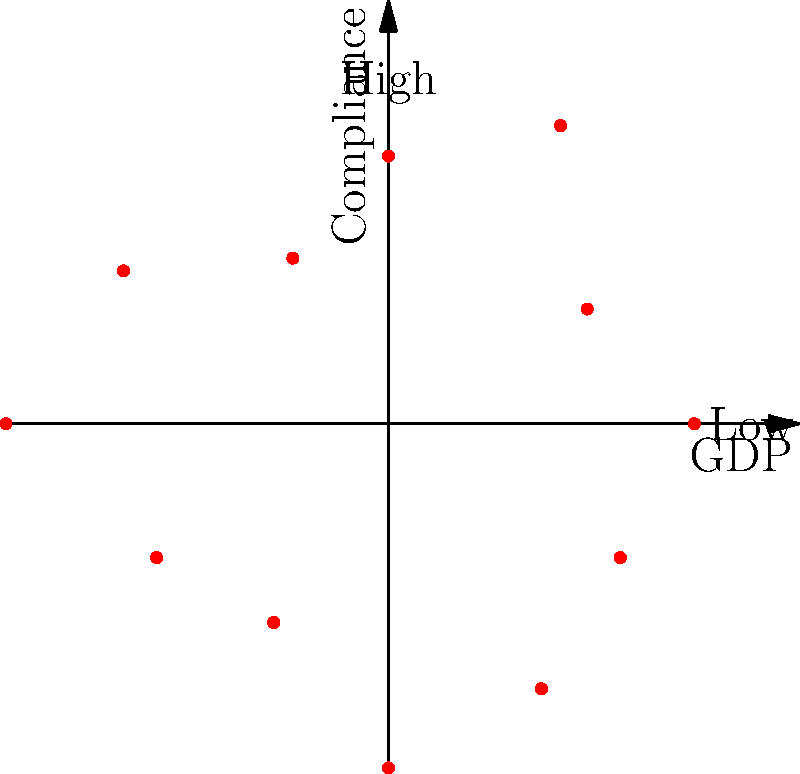The polar scatter plot shows the relationship between GDP (radial distance) and compliance with international environmental laws (angular position) for 12 countries. Which quadrant of the plot suggests countries with high GDP and high compliance? To answer this question, we need to analyze the polar scatter plot:

1. The radial distance from the center represents GDP:
   - Points closer to the center indicate lower GDP
   - Points farther from the center indicate higher GDP

2. The angular position represents compliance with international environmental laws:
   - 0° (right) represents low compliance
   - 90° (top) represents high compliance

3. The plot is divided into four quadrants:
   - Q1 (top-right): 0° to 90°
   - Q2 (top-left): 90° to 180°
   - Q3 (bottom-left): 180° to 270°
   - Q4 (bottom-right): 270° to 360°

4. Countries with high GDP and high compliance would be located:
   - Far from the center (high GDP)
   - Close to the 90° position (high compliance)

5. Examining the plot, we can see that the points in Q1 (top-right quadrant) best fit these criteria:
   - They are generally farther from the center
   - They are closer to the 90° position

Therefore, the quadrant that suggests countries with high GDP and high compliance is the top-right quadrant (Q1).
Answer: Top-right quadrant (Q1) 